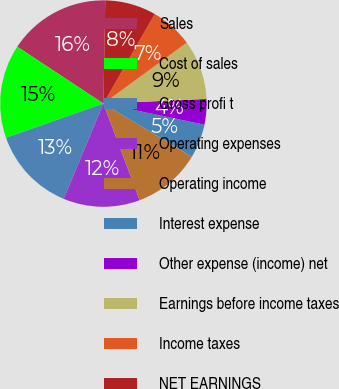<chart> <loc_0><loc_0><loc_500><loc_500><pie_chart><fcel>Sales<fcel>Cost of sales<fcel>Gross profi t<fcel>Operating expenses<fcel>Operating income<fcel>Interest expense<fcel>Other expense (income) net<fcel>Earnings before income taxes<fcel>Income taxes<fcel>NET EARNINGS<nl><fcel>16.0%<fcel>14.67%<fcel>13.33%<fcel>12.0%<fcel>10.67%<fcel>5.33%<fcel>4.0%<fcel>9.33%<fcel>6.67%<fcel>8.0%<nl></chart> 